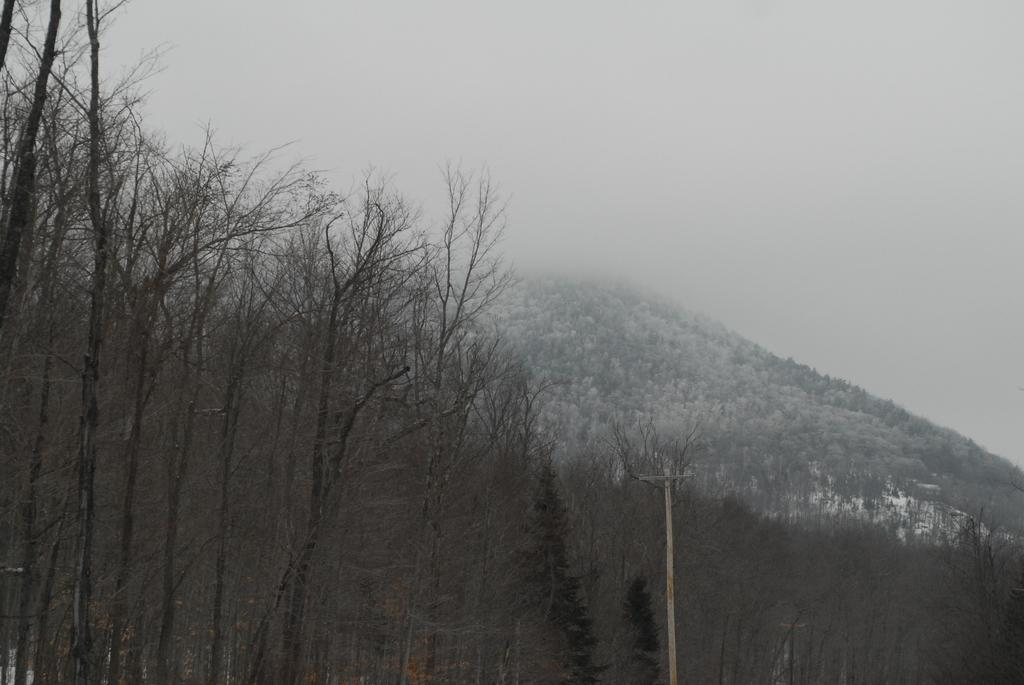What type of vegetation can be seen in the image? There are trees in the image. What structure is present in the image? There is a pole in the image. What geographical feature is visible in the background of the image? There is a hill in the background of the image. What atmospheric condition is present in the image? There is fog visible in the image. What position does the locket hold in the image? There is no locket present in the image. How does the wind affect the trees in the image? The image does not show any wind, so we cannot determine its effect on the trees. 